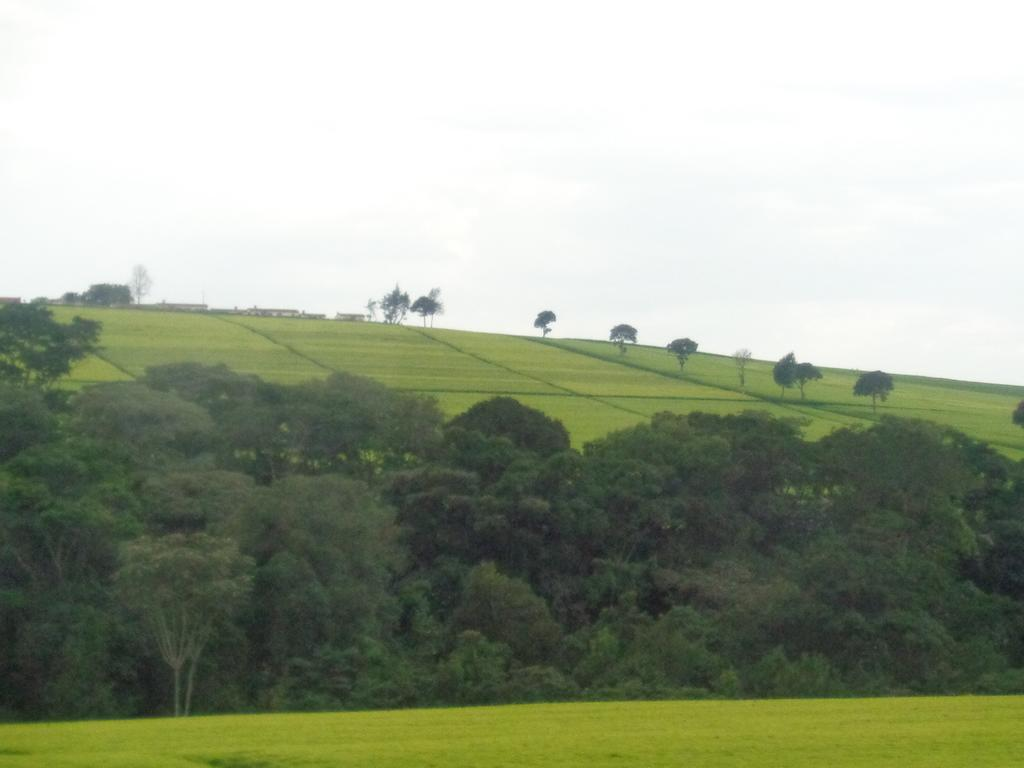What type of vegetation is predominant in the image? There are many trees in the image. What is the condition of the land in the image? The land is full of grass. What color is the sky in the image? The sky is white in color. What type of cable can be seen hanging from the trees in the image? There is no cable present in the image; it only features trees, grass, and a white sky. 